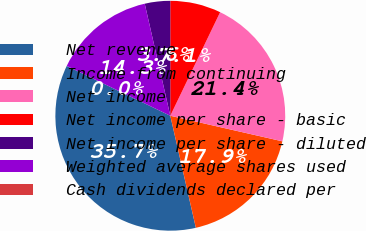Convert chart to OTSL. <chart><loc_0><loc_0><loc_500><loc_500><pie_chart><fcel>Net revenue<fcel>Income from continuing<fcel>Net income<fcel>Net income per share - basic<fcel>Net income per share - diluted<fcel>Weighted average shares used<fcel>Cash dividends declared per<nl><fcel>35.71%<fcel>17.86%<fcel>21.43%<fcel>7.14%<fcel>3.57%<fcel>14.29%<fcel>0.0%<nl></chart> 